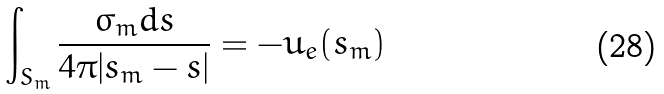<formula> <loc_0><loc_0><loc_500><loc_500>\int _ { S _ { m } } \frac { \sigma _ { m } d s } { 4 \pi | s _ { m } - s | } = - u _ { e } ( s _ { m } )</formula> 